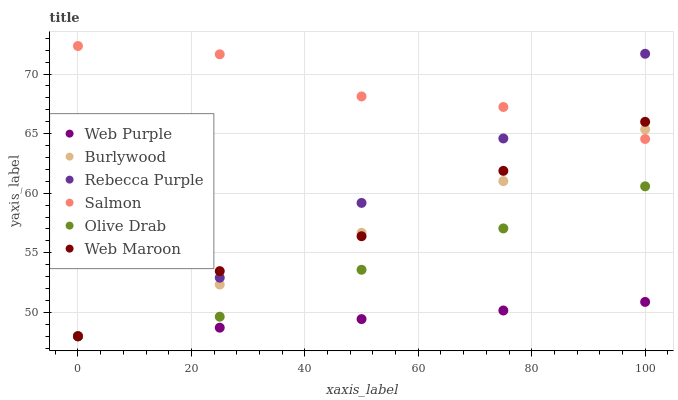Does Web Purple have the minimum area under the curve?
Answer yes or no. Yes. Does Salmon have the maximum area under the curve?
Answer yes or no. Yes. Does Web Maroon have the minimum area under the curve?
Answer yes or no. No. Does Web Maroon have the maximum area under the curve?
Answer yes or no. No. Is Burlywood the smoothest?
Answer yes or no. Yes. Is Salmon the roughest?
Answer yes or no. Yes. Is Web Maroon the smoothest?
Answer yes or no. No. Is Web Maroon the roughest?
Answer yes or no. No. Does Burlywood have the lowest value?
Answer yes or no. Yes. Does Salmon have the lowest value?
Answer yes or no. No. Does Salmon have the highest value?
Answer yes or no. Yes. Does Web Maroon have the highest value?
Answer yes or no. No. Is Olive Drab less than Salmon?
Answer yes or no. Yes. Is Salmon greater than Web Purple?
Answer yes or no. Yes. Does Salmon intersect Web Maroon?
Answer yes or no. Yes. Is Salmon less than Web Maroon?
Answer yes or no. No. Is Salmon greater than Web Maroon?
Answer yes or no. No. Does Olive Drab intersect Salmon?
Answer yes or no. No. 